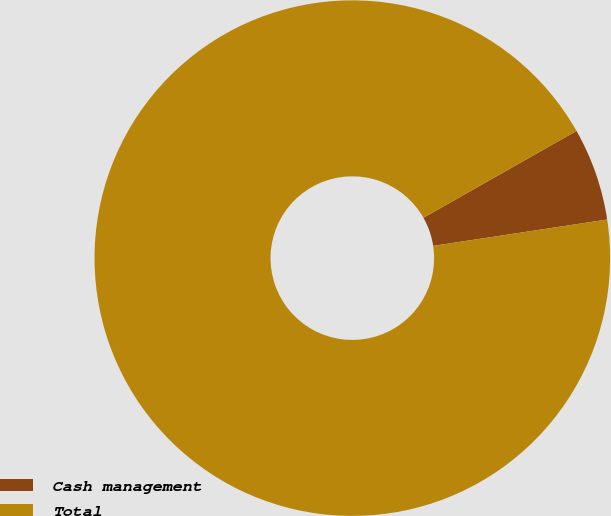Convert chart to OTSL. <chart><loc_0><loc_0><loc_500><loc_500><pie_chart><fcel>Cash management<fcel>Total<nl><fcel>5.82%<fcel>94.18%<nl></chart> 